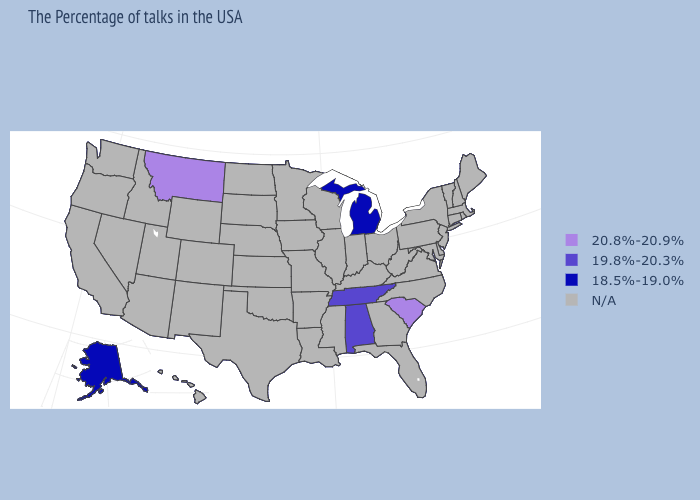What is the value of Colorado?
Quick response, please. N/A. What is the value of New Mexico?
Keep it brief. N/A. Which states have the lowest value in the West?
Short answer required. Alaska. Name the states that have a value in the range N/A?
Write a very short answer. Maine, Massachusetts, Rhode Island, New Hampshire, Vermont, Connecticut, New York, New Jersey, Delaware, Maryland, Pennsylvania, Virginia, North Carolina, West Virginia, Ohio, Florida, Georgia, Kentucky, Indiana, Wisconsin, Illinois, Mississippi, Louisiana, Missouri, Arkansas, Minnesota, Iowa, Kansas, Nebraska, Oklahoma, Texas, South Dakota, North Dakota, Wyoming, Colorado, New Mexico, Utah, Arizona, Idaho, Nevada, California, Washington, Oregon, Hawaii. Which states have the lowest value in the USA?
Be succinct. Michigan, Alaska. What is the lowest value in the South?
Be succinct. 19.8%-20.3%. Does the map have missing data?
Short answer required. Yes. Name the states that have a value in the range 20.8%-20.9%?
Give a very brief answer. South Carolina, Montana. Does the map have missing data?
Write a very short answer. Yes. Is the legend a continuous bar?
Write a very short answer. No. Name the states that have a value in the range 19.8%-20.3%?
Quick response, please. Alabama, Tennessee. What is the value of West Virginia?
Concise answer only. N/A. What is the lowest value in the USA?
Short answer required. 18.5%-19.0%. What is the value of Delaware?
Quick response, please. N/A. Name the states that have a value in the range N/A?
Quick response, please. Maine, Massachusetts, Rhode Island, New Hampshire, Vermont, Connecticut, New York, New Jersey, Delaware, Maryland, Pennsylvania, Virginia, North Carolina, West Virginia, Ohio, Florida, Georgia, Kentucky, Indiana, Wisconsin, Illinois, Mississippi, Louisiana, Missouri, Arkansas, Minnesota, Iowa, Kansas, Nebraska, Oklahoma, Texas, South Dakota, North Dakota, Wyoming, Colorado, New Mexico, Utah, Arizona, Idaho, Nevada, California, Washington, Oregon, Hawaii. 